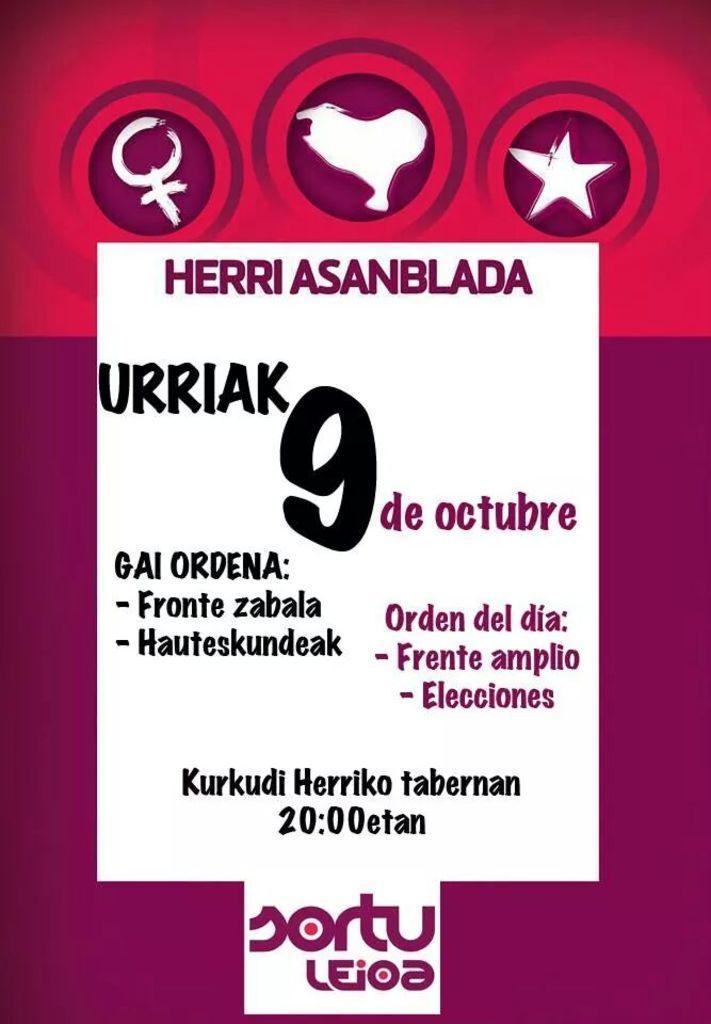In one or two sentences, can you explain what this image depicts? In the image there is a graphic image with some text in the middle and some icons above it. 